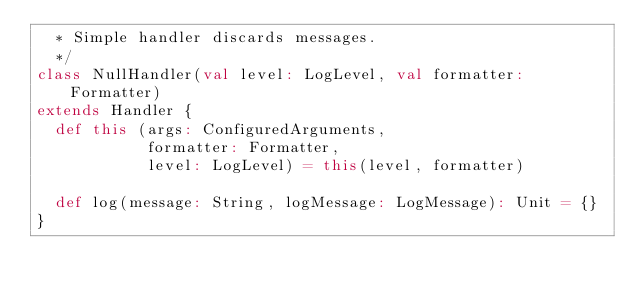<code> <loc_0><loc_0><loc_500><loc_500><_Scala_>  * Simple handler discards messages.
  */
class NullHandler(val level: LogLevel, val formatter: Formatter)
extends Handler {
  def this (args: ConfiguredArguments,
            formatter: Formatter,
            level: LogLevel) = this(level, formatter)

  def log(message: String, logMessage: LogMessage): Unit = {}
}
</code> 